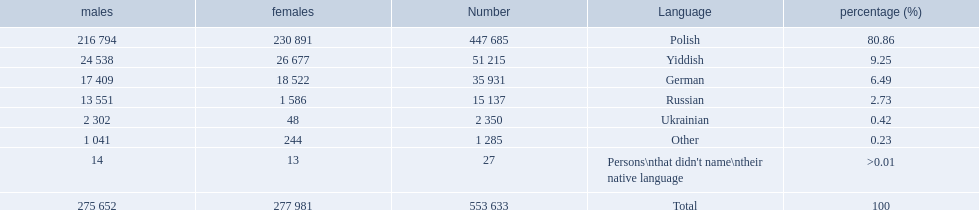Could you help me parse every detail presented in this table? {'header': ['males', 'females', 'Number', 'Language', 'percentage (%)'], 'rows': [['216 794', '230 891', '447 685', 'Polish', '80.86'], ['24 538', '26 677', '51 215', 'Yiddish', '9.25'], ['17 409', '18 522', '35 931', 'German', '6.49'], ['13 551', '1 586', '15 137', 'Russian', '2.73'], ['2 302', '48', '2 350', 'Ukrainian', '0.42'], ['1 041', '244', '1 285', 'Other', '0.23'], ['14', '13', '27', "Persons\\nthat didn't name\\ntheir native language", '>0.01'], ['275 652', '277 981', '553 633', 'Total', '100']]} What are the percentages of people? 80.86, 9.25, 6.49, 2.73, 0.42, 0.23, >0.01. Which language is .42%? Ukrainian. 